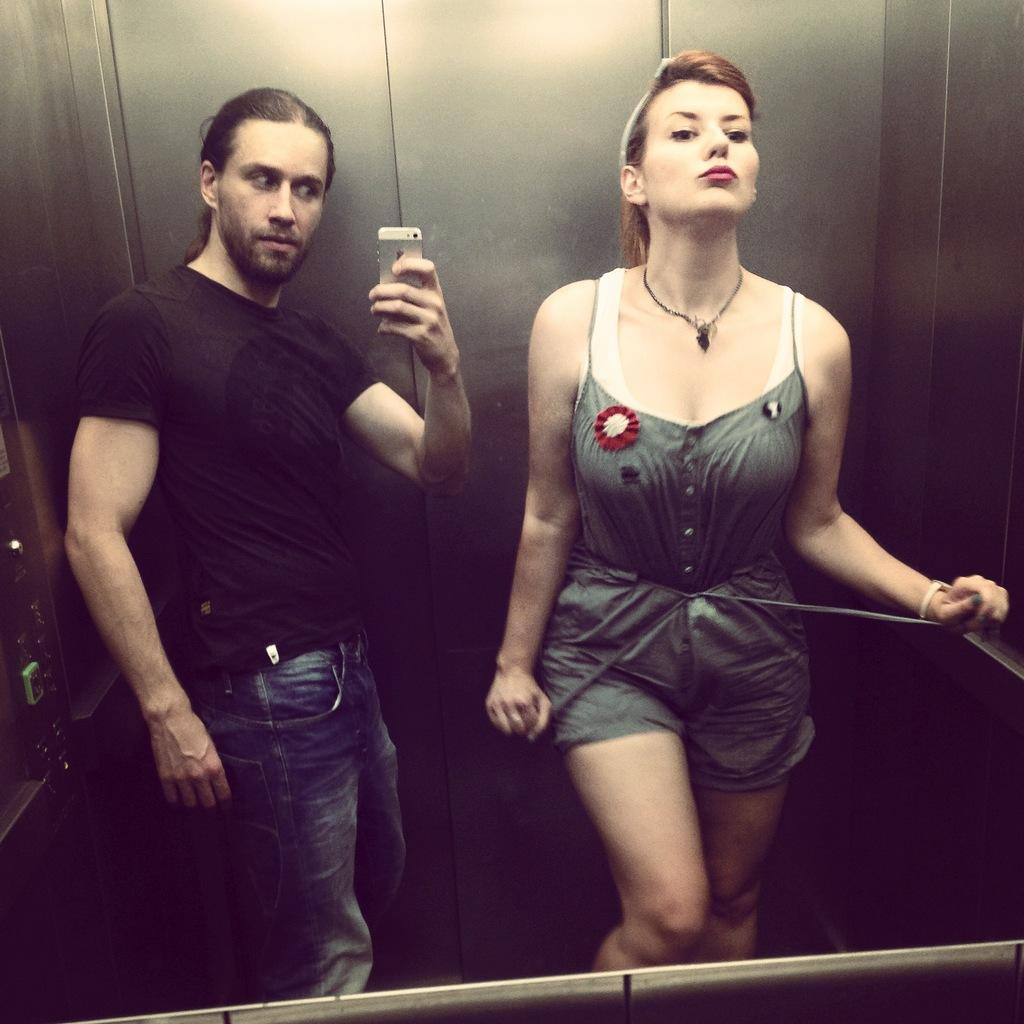Who are the people in the image? There is a man and a woman in the image. What is the man holding in the image? The man is holding a mobile in the image. What can be seen in the background of the image? There is a steel wall in the background of the image. What type of fear is the man experiencing in the image? There is no indication of fear in the image; the man is holding a mobile. Can you describe the cub that is present in the image? There is no cub present in the image. 